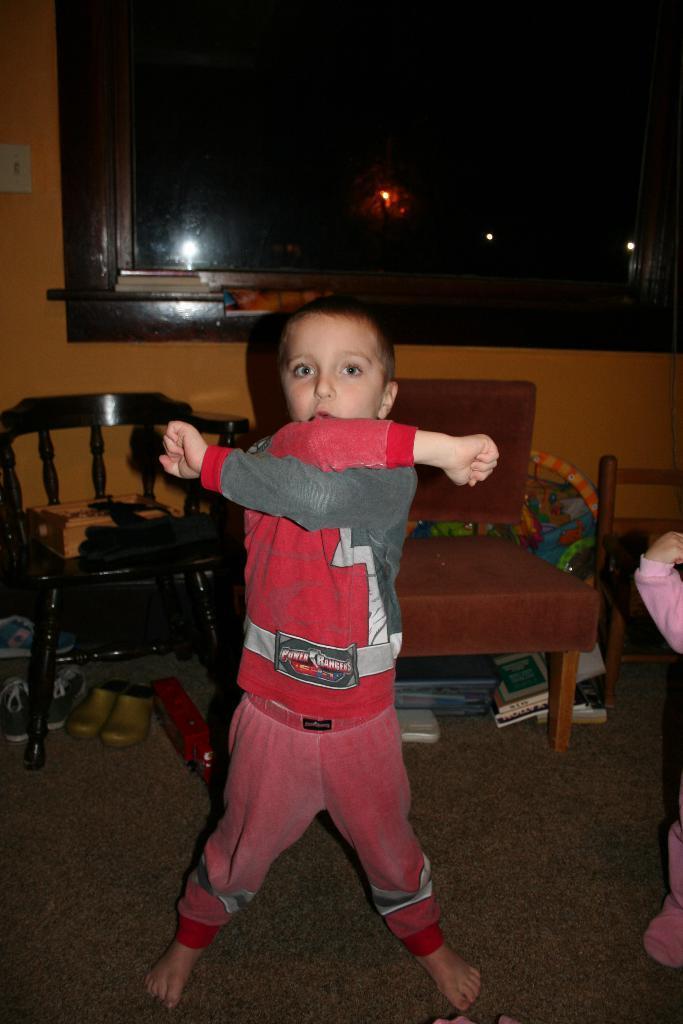In one or two sentences, can you explain what this image depicts? This picture shows a boy posing for a picture. In the background there are some chairs and a window here. 